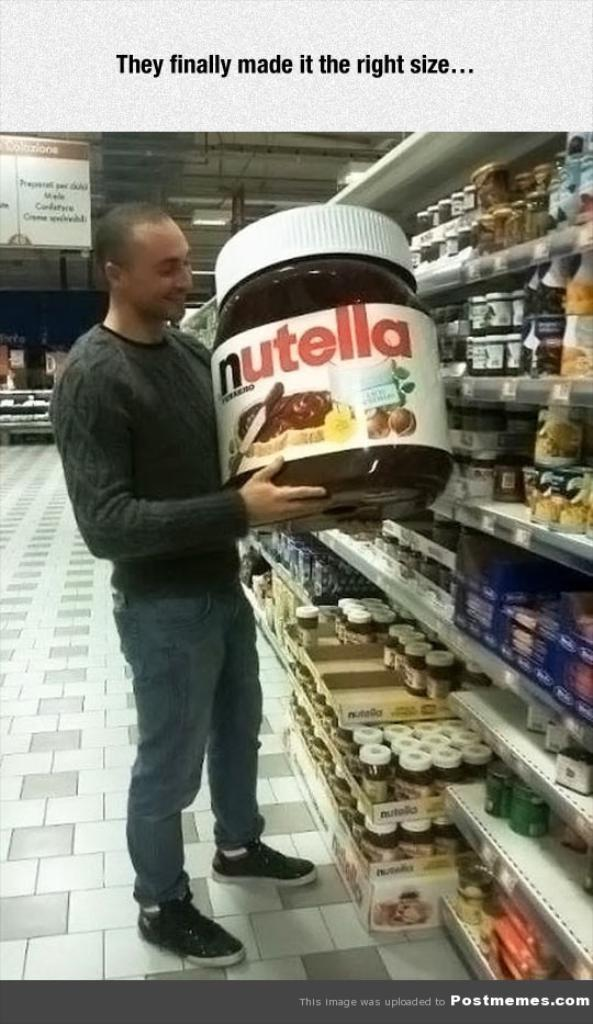<image>
Share a concise interpretation of the image provided. A man holds a giant tub of nutella. 